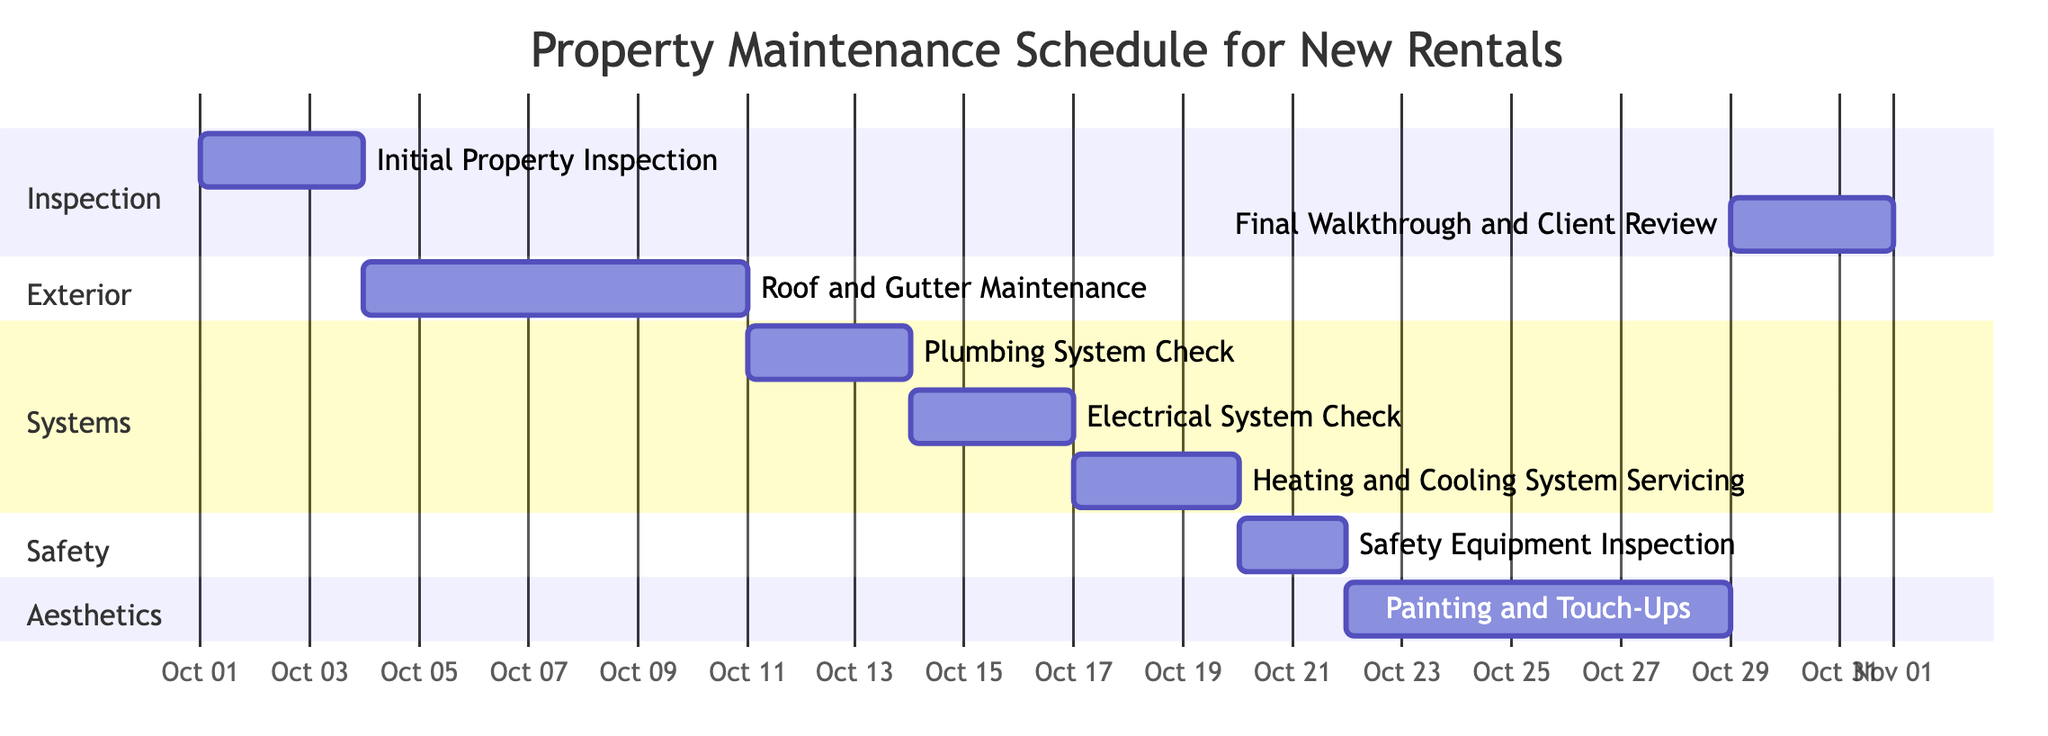What is the duration of the Roof and Gutter Maintenance task? The task of Roof and Gutter Maintenance starts on October 4 and ends on October 10, so the duration is calculated as the end date minus the start date. That is 7 days in total.
Answer: 7 days When does the Safety Equipment Inspection occur? The Safety Equipment Inspection is scheduled to start on October 20 and end on October 21, which makes it a 2-day task. Hence, it occurs on these specific dates.
Answer: October 20 - 21 How many sections are in the Gantt chart? The chart has five distinct sections labeled as Inspection, Exterior, Systems, Safety, and Aesthetics. By counting these labeled sections, we find there are five.
Answer: 5 Which task follows the Plumbing System Check? The Plumbing System Check ends on October 13. The next task, following this, is the Electrical System Check which starts on October 14. Thus, the task directly subsequent to the Plumbing System Check is the Electrical System Check.
Answer: Electrical System Check What is the total number of days for the entire maintenance schedule? The maintenance starts with the Initial Property Inspection on October 1 and ends with the Final Walkthrough and Client Review on October 31. The total duration can be calculated by counting all days from the start to the end, which is a total of 31 days.
Answer: 31 days Which task has the longest duration? By examining each task's duration, we see that the Painting and Touch-Ups task extends from October 22 to October 28, lasting 7 days. Therefore, it has the longest duration compared to the other tasks.
Answer: Painting and Touch-Ups What is the time gap between the Heating and Cooling System Servicing and the Final Walkthrough and Client Review? The Heating and Cooling System Servicing ends on October 19, while the Final Walkthrough and Client Review starts on October 29. Therefore, we calculate the gap between these two dates, which is 10 days.
Answer: 10 days How many inspections are included in the maintenance schedule? The maintenance schedule lists two inspection tasks: the Initial Property Inspection and the Safety Equipment Inspection. Thus, the total number of inspections is two.
Answer: 2 